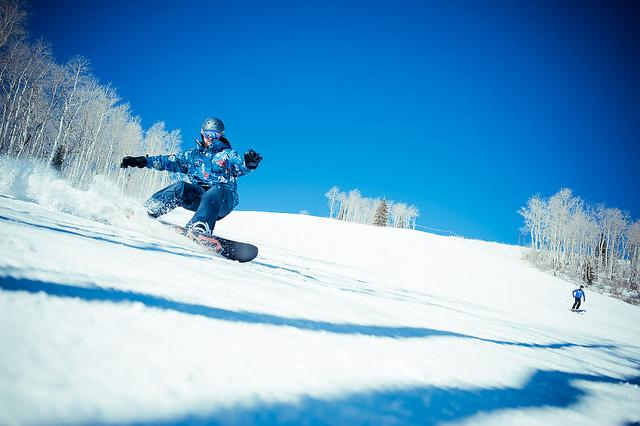In which direction is this snowboarder moving? Please explain your reasoning. right. The snowboarder seems to be going on the right. 